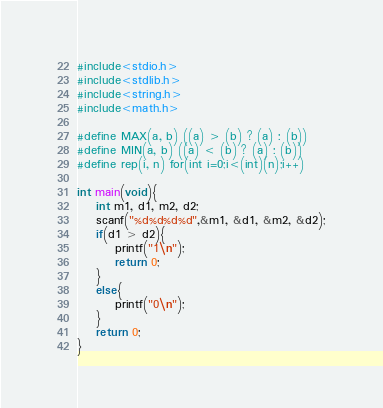Convert code to text. <code><loc_0><loc_0><loc_500><loc_500><_C_>#include<stdio.h>
#include<stdlib.h>
#include<string.h>
#include<math.h>

#define MAX(a, b) ((a) > (b) ? (a) : (b))
#define MIN(a, b) ((a) < (b) ? (a) : (b))
#define rep(i, n) for(int i=0;i<(int)(n);i++)

int main(void){
	int m1, d1, m2, d2;
	scanf("%d%d%d%d",&m1, &d1, &m2, &d2);
	if(d1 > d2){
		printf("1\n");
		return 0;
	}
	else{
		printf("0\n");
	}
    return 0; 
}
</code> 